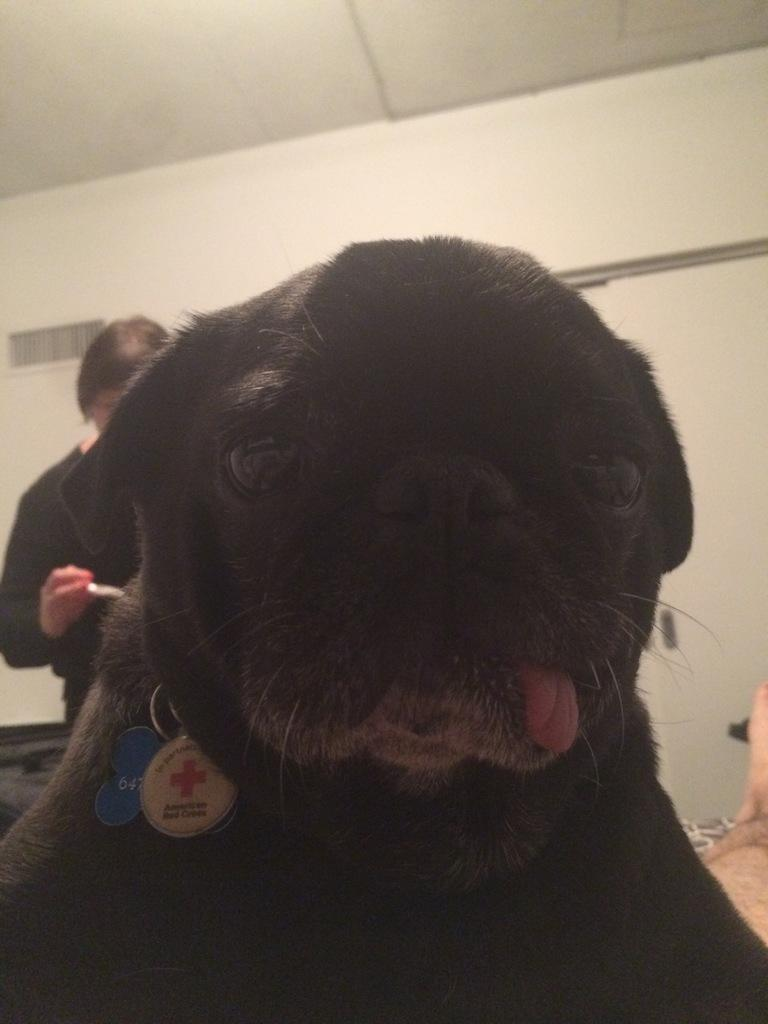What type of animal is in the image? There is a black color dog in the image. Can you describe the setting of the image? There is a person standing in the background of the image, and there is a wall in the background as well. How many balls can be seen in the image? There are no balls present in the image. What type of lead is the dog using to walk in the image? The dog is not walking in the image, and there is no mention of a lead. 